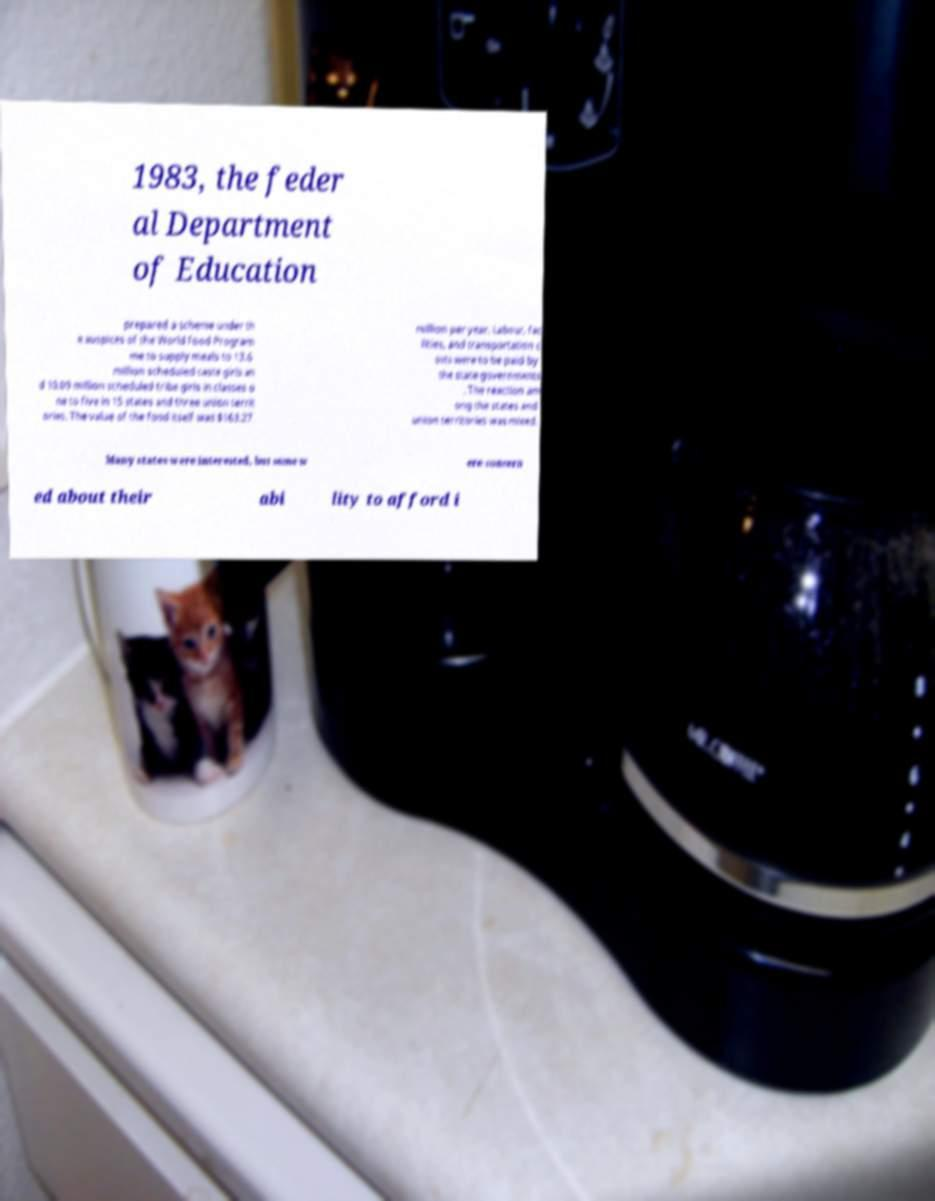I need the written content from this picture converted into text. Can you do that? 1983, the feder al Department of Education prepared a scheme under th e auspices of the World Food Program me to supply meals to 13.6 million scheduled caste girls an d 10.09 million scheduled tribe girls in classes o ne to five in 15 states and three union territ ories. The value of the food itself was $163.27 million per year. Labour, fac ilities, and transportation c osts were to be paid by the state governments . The reaction am ong the states and union territories was mixed. Many states were interested, but some w ere concern ed about their abi lity to afford i 